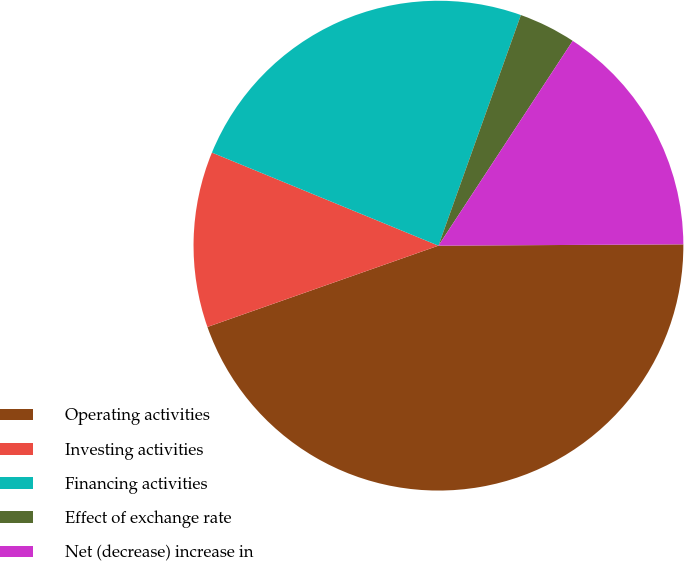Convert chart. <chart><loc_0><loc_0><loc_500><loc_500><pie_chart><fcel>Operating activities<fcel>Investing activities<fcel>Financing activities<fcel>Effect of exchange rate<fcel>Net (decrease) increase in<nl><fcel>44.7%<fcel>11.59%<fcel>24.26%<fcel>3.77%<fcel>15.68%<nl></chart> 